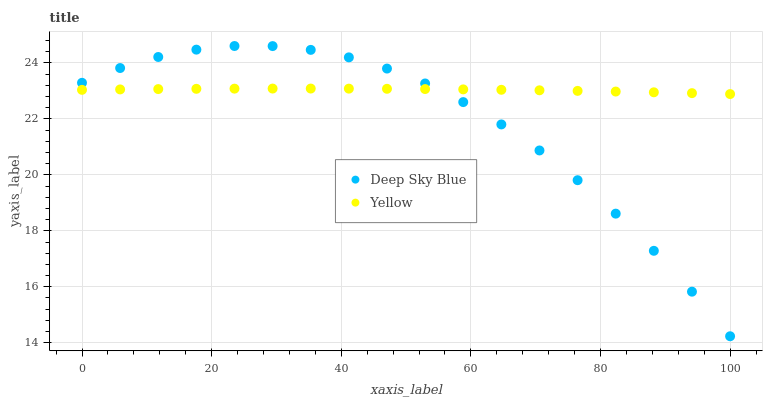Does Deep Sky Blue have the minimum area under the curve?
Answer yes or no. Yes. Does Yellow have the maximum area under the curve?
Answer yes or no. Yes. Does Deep Sky Blue have the maximum area under the curve?
Answer yes or no. No. Is Yellow the smoothest?
Answer yes or no. Yes. Is Deep Sky Blue the roughest?
Answer yes or no. Yes. Is Deep Sky Blue the smoothest?
Answer yes or no. No. Does Deep Sky Blue have the lowest value?
Answer yes or no. Yes. Does Deep Sky Blue have the highest value?
Answer yes or no. Yes. Does Deep Sky Blue intersect Yellow?
Answer yes or no. Yes. Is Deep Sky Blue less than Yellow?
Answer yes or no. No. Is Deep Sky Blue greater than Yellow?
Answer yes or no. No. 